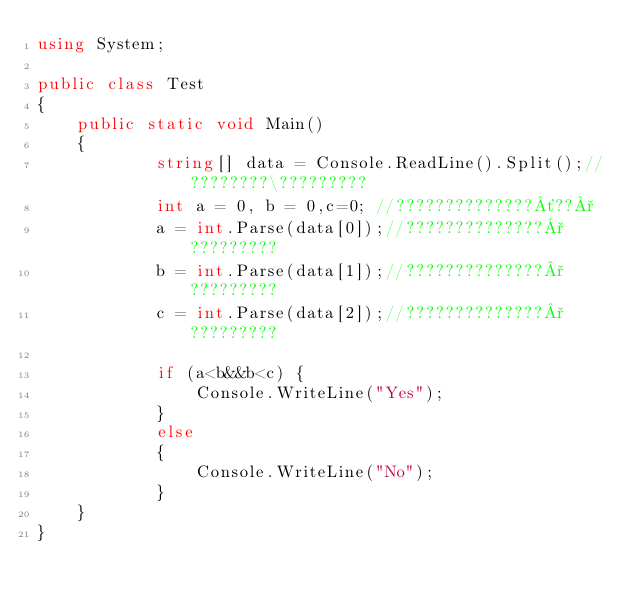Convert code to text. <code><loc_0><loc_0><loc_500><loc_500><_C#_>using System;

public class Test
{
	public static void Main()
	{
	        string[] data = Console.ReadLine().Split();//????????\?????????
            int a = 0, b = 0,c=0; //??????????????´??°
            a = int.Parse(data[0]);//??????????????°?????????
            b = int.Parse(data[1]);//??????????????°?????????
            c = int.Parse(data[2]);//??????????????°?????????

            if (a<b&&b<c) {
                Console.WriteLine("Yes");
            }
            else
            {
                Console.WriteLine("No");
            }
	}
}</code> 